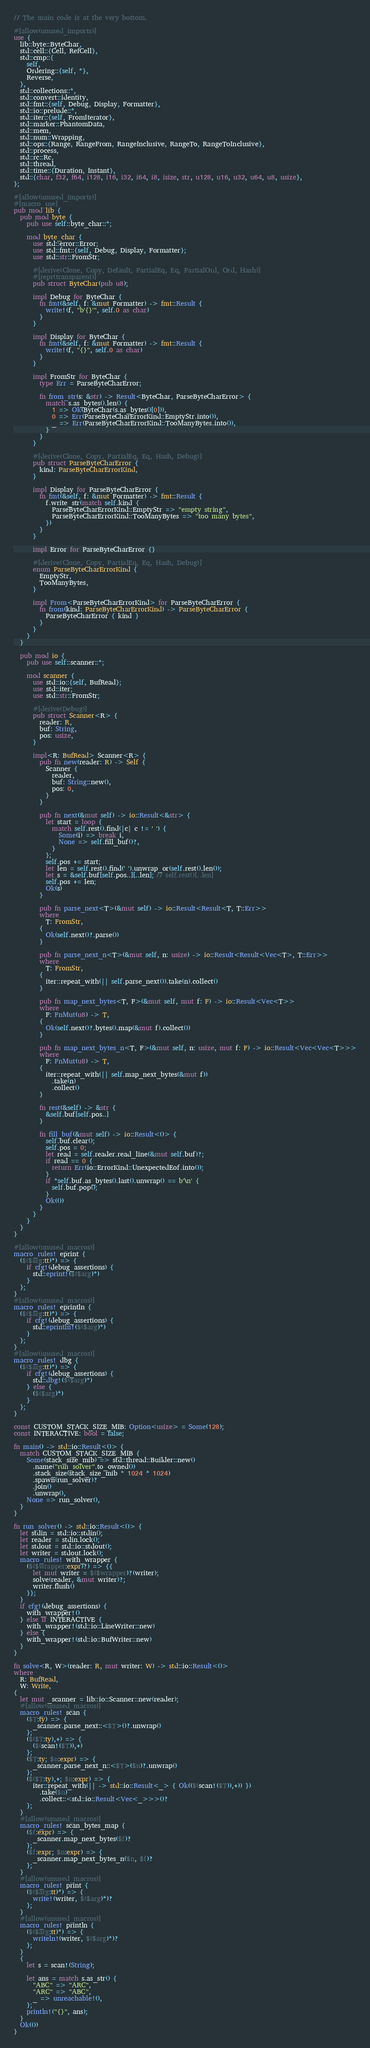<code> <loc_0><loc_0><loc_500><loc_500><_Rust_>// The main code is at the very bottom.

#[allow(unused_imports)]
use {
  lib::byte::ByteChar,
  std::cell::{Cell, RefCell},
  std::cmp::{
    self,
    Ordering::{self, *},
    Reverse,
  },
  std::collections::*,
  std::convert::identity,
  std::fmt::{self, Debug, Display, Formatter},
  std::io::prelude::*,
  std::iter::{self, FromIterator},
  std::marker::PhantomData,
  std::mem,
  std::num::Wrapping,
  std::ops::{Range, RangeFrom, RangeInclusive, RangeTo, RangeToInclusive},
  std::process,
  std::rc::Rc,
  std::thread,
  std::time::{Duration, Instant},
  std::{char, f32, f64, i128, i16, i32, i64, i8, isize, str, u128, u16, u32, u64, u8, usize},
};

#[allow(unused_imports)]
#[macro_use]
pub mod lib {
  pub mod byte {
    pub use self::byte_char::*;

    mod byte_char {
      use std::error::Error;
      use std::fmt::{self, Debug, Display, Formatter};
      use std::str::FromStr;

      #[derive(Clone, Copy, Default, PartialEq, Eq, PartialOrd, Ord, Hash)]
      #[repr(transparent)]
      pub struct ByteChar(pub u8);

      impl Debug for ByteChar {
        fn fmt(&self, f: &mut Formatter) -> fmt::Result {
          write!(f, "b'{}'", self.0 as char)
        }
      }

      impl Display for ByteChar {
        fn fmt(&self, f: &mut Formatter) -> fmt::Result {
          write!(f, "{}", self.0 as char)
        }
      }

      impl FromStr for ByteChar {
        type Err = ParseByteCharError;

        fn from_str(s: &str) -> Result<ByteChar, ParseByteCharError> {
          match s.as_bytes().len() {
            1 => Ok(ByteChar(s.as_bytes()[0])),
            0 => Err(ParseByteCharErrorKind::EmptyStr.into()),
            _ => Err(ParseByteCharErrorKind::TooManyBytes.into()),
          }
        }
      }

      #[derive(Clone, Copy, PartialEq, Eq, Hash, Debug)]
      pub struct ParseByteCharError {
        kind: ParseByteCharErrorKind,
      }

      impl Display for ParseByteCharError {
        fn fmt(&self, f: &mut Formatter) -> fmt::Result {
          f.write_str(match self.kind {
            ParseByteCharErrorKind::EmptyStr => "empty string",
            ParseByteCharErrorKind::TooManyBytes => "too many bytes",
          })
        }
      }

      impl Error for ParseByteCharError {}

      #[derive(Clone, Copy, PartialEq, Eq, Hash, Debug)]
      enum ParseByteCharErrorKind {
        EmptyStr,
        TooManyBytes,
      }

      impl From<ParseByteCharErrorKind> for ParseByteCharError {
        fn from(kind: ParseByteCharErrorKind) -> ParseByteCharError {
          ParseByteCharError { kind }
        }
      }
    }
  }

  pub mod io {
    pub use self::scanner::*;

    mod scanner {
      use std::io::{self, BufRead};
      use std::iter;
      use std::str::FromStr;

      #[derive(Debug)]
      pub struct Scanner<R> {
        reader: R,
        buf: String,
        pos: usize,
      }

      impl<R: BufRead> Scanner<R> {
        pub fn new(reader: R) -> Self {
          Scanner {
            reader,
            buf: String::new(),
            pos: 0,
          }
        }

        pub fn next(&mut self) -> io::Result<&str> {
          let start = loop {
            match self.rest().find(|c| c != ' ') {
              Some(i) => break i,
              None => self.fill_buf()?,
            }
          };
          self.pos += start;
          let len = self.rest().find(' ').unwrap_or(self.rest().len());
          let s = &self.buf[self.pos..][..len]; // self.rest()[..len]
          self.pos += len;
          Ok(s)
        }

        pub fn parse_next<T>(&mut self) -> io::Result<Result<T, T::Err>>
        where
          T: FromStr,
        {
          Ok(self.next()?.parse())
        }

        pub fn parse_next_n<T>(&mut self, n: usize) -> io::Result<Result<Vec<T>, T::Err>>
        where
          T: FromStr,
        {
          iter::repeat_with(|| self.parse_next()).take(n).collect()
        }

        pub fn map_next_bytes<T, F>(&mut self, mut f: F) -> io::Result<Vec<T>>
        where
          F: FnMut(u8) -> T,
        {
          Ok(self.next()?.bytes().map(&mut f).collect())
        }

        pub fn map_next_bytes_n<T, F>(&mut self, n: usize, mut f: F) -> io::Result<Vec<Vec<T>>>
        where
          F: FnMut(u8) -> T,
        {
          iter::repeat_with(|| self.map_next_bytes(&mut f))
            .take(n)
            .collect()
        }

        fn rest(&self) -> &str {
          &self.buf[self.pos..]
        }

        fn fill_buf(&mut self) -> io::Result<()> {
          self.buf.clear();
          self.pos = 0;
          let read = self.reader.read_line(&mut self.buf)?;
          if read == 0 {
            return Err(io::ErrorKind::UnexpectedEof.into());
          }
          if *self.buf.as_bytes().last().unwrap() == b'\n' {
            self.buf.pop();
          }
          Ok(())
        }
      }
    }
  }
}

#[allow(unused_macros)]
macro_rules! eprint {
  ($($arg:tt)*) => {
    if cfg!(debug_assertions) {
      std::eprint!($($arg)*)
    }
  };
}
#[allow(unused_macros)]
macro_rules! eprintln {
  ($($arg:tt)*) => {
    if cfg!(debug_assertions) {
      std::eprintln!($($arg)*)
    }
  };
}
#[allow(unused_macros)]
macro_rules! dbg {
  ($($arg:tt)*) => {
    if cfg!(debug_assertions) {
      std::dbg!($($arg)*)
    } else {
      ($($arg)*)
    }
  };
}

const CUSTOM_STACK_SIZE_MIB: Option<usize> = Some(128);
const INTERACTIVE: bool = false;

fn main() -> std::io::Result<()> {
  match CUSTOM_STACK_SIZE_MIB {
    Some(stack_size_mib) => std::thread::Builder::new()
      .name("run_solver".to_owned())
      .stack_size(stack_size_mib * 1024 * 1024)
      .spawn(run_solver)?
      .join()
      .unwrap(),
    None => run_solver(),
  }
}

fn run_solver() -> std::io::Result<()> {
  let stdin = std::io::stdin();
  let reader = stdin.lock();
  let stdout = std::io::stdout();
  let writer = stdout.lock();
  macro_rules! with_wrapper {
    ($($wrapper:expr)?) => {{
      let mut writer = $($wrapper)?(writer);
      solve(reader, &mut writer)?;
      writer.flush()
    }};
  }
  if cfg!(debug_assertions) {
    with_wrapper!()
  } else if INTERACTIVE {
    with_wrapper!(std::io::LineWriter::new)
  } else {
    with_wrapper!(std::io::BufWriter::new)
  }
}

fn solve<R, W>(reader: R, mut writer: W) -> std::io::Result<()>
where
  R: BufRead,
  W: Write,
{
  let mut _scanner = lib::io::Scanner::new(reader);
  #[allow(unused_macros)]
  macro_rules! scan {
    ($T:ty) => {
      _scanner.parse_next::<$T>()?.unwrap()
    };
    ($($T:ty),+) => {
      ($(scan!($T)),+)
    };
    ($T:ty; $n:expr) => {
      _scanner.parse_next_n::<$T>($n)?.unwrap()
    };
    ($($T:ty),+; $n:expr) => {
      iter::repeat_with(|| -> std::io::Result<_> { Ok(($(scan!($T)),+)) })
        .take($n)
        .collect::<std::io::Result<Vec<_>>>()?
    };
  }
  #[allow(unused_macros)]
  macro_rules! scan_bytes_map {
    ($f:expr) => {
      _scanner.map_next_bytes($f)?
    };
    ($f:expr; $n:expr) => {
      _scanner.map_next_bytes_n($n, $f)?
    };
  }
  #[allow(unused_macros)]
  macro_rules! print {
    ($($arg:tt)*) => {
      write!(writer, $($arg)*)?
    };
  }
  #[allow(unused_macros)]
  macro_rules! println {
    ($($arg:tt)*) => {
      writeln!(writer, $($arg)*)?
    };
  }
  {
    let s = scan!(String);

    let ans = match s.as_str() {
      "ABC" => "ARC",
      "ARC" => "ABC",
      _ => unreachable!(),
    };
    println!("{}", ans);
  }
  Ok(())
}
</code> 